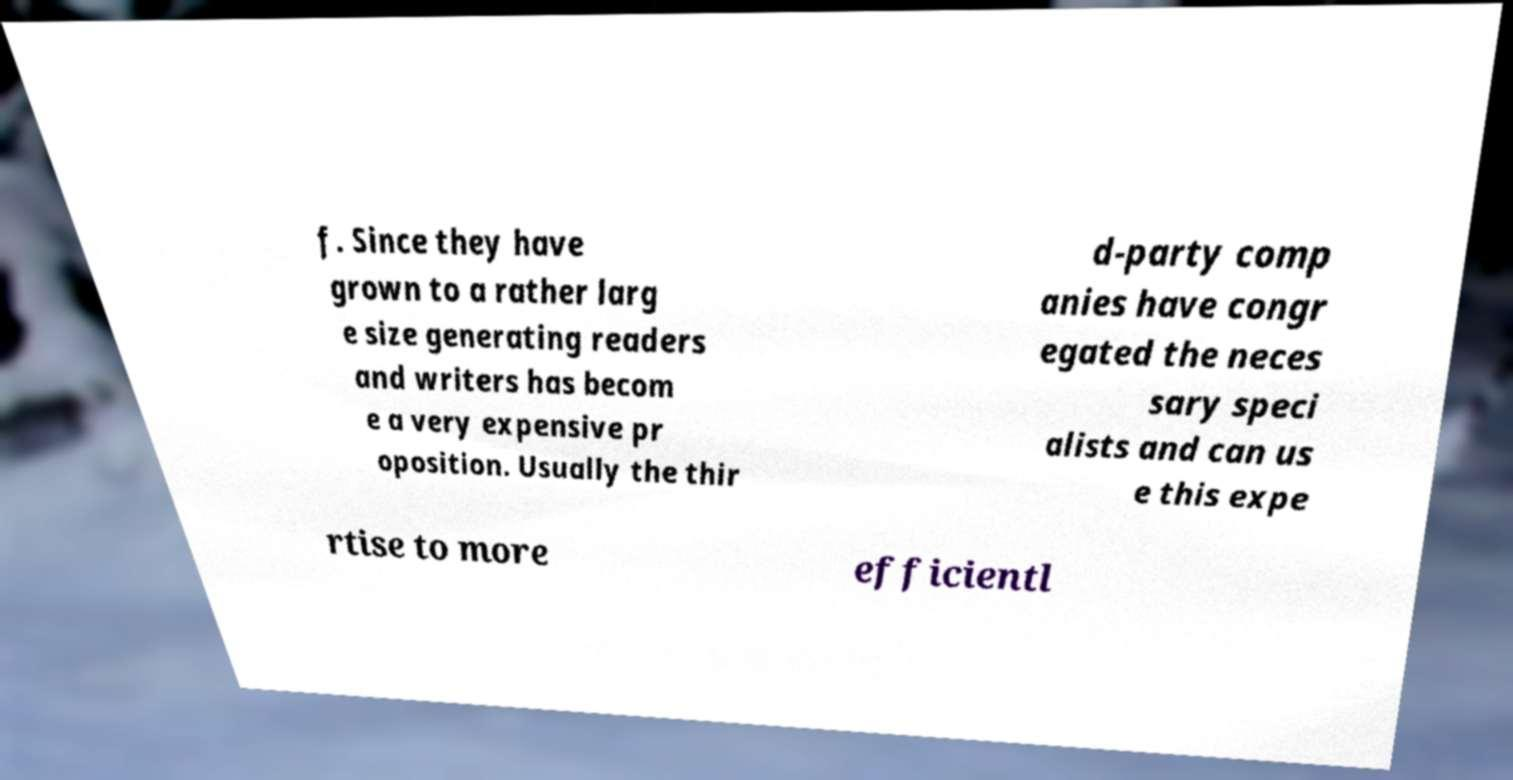What messages or text are displayed in this image? I need them in a readable, typed format. f. Since they have grown to a rather larg e size generating readers and writers has becom e a very expensive pr oposition. Usually the thir d-party comp anies have congr egated the neces sary speci alists and can us e this expe rtise to more efficientl 